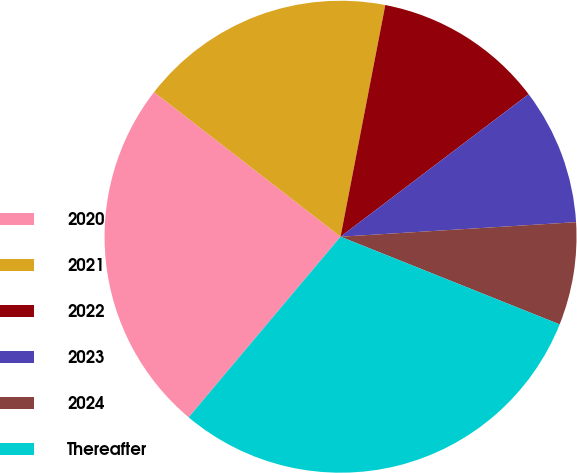Convert chart to OTSL. <chart><loc_0><loc_0><loc_500><loc_500><pie_chart><fcel>2020<fcel>2021<fcel>2022<fcel>2023<fcel>2024<fcel>Thereafter<nl><fcel>24.37%<fcel>17.54%<fcel>11.64%<fcel>9.34%<fcel>7.04%<fcel>30.07%<nl></chart> 